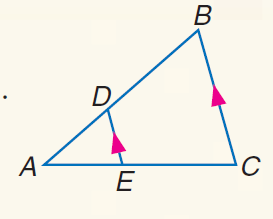Answer the mathemtical geometry problem and directly provide the correct option letter.
Question: If A D = 8, A E = 12, and E C = 18, find A B.
Choices: A: 15 B: 16 C: 18 D: 20 D 